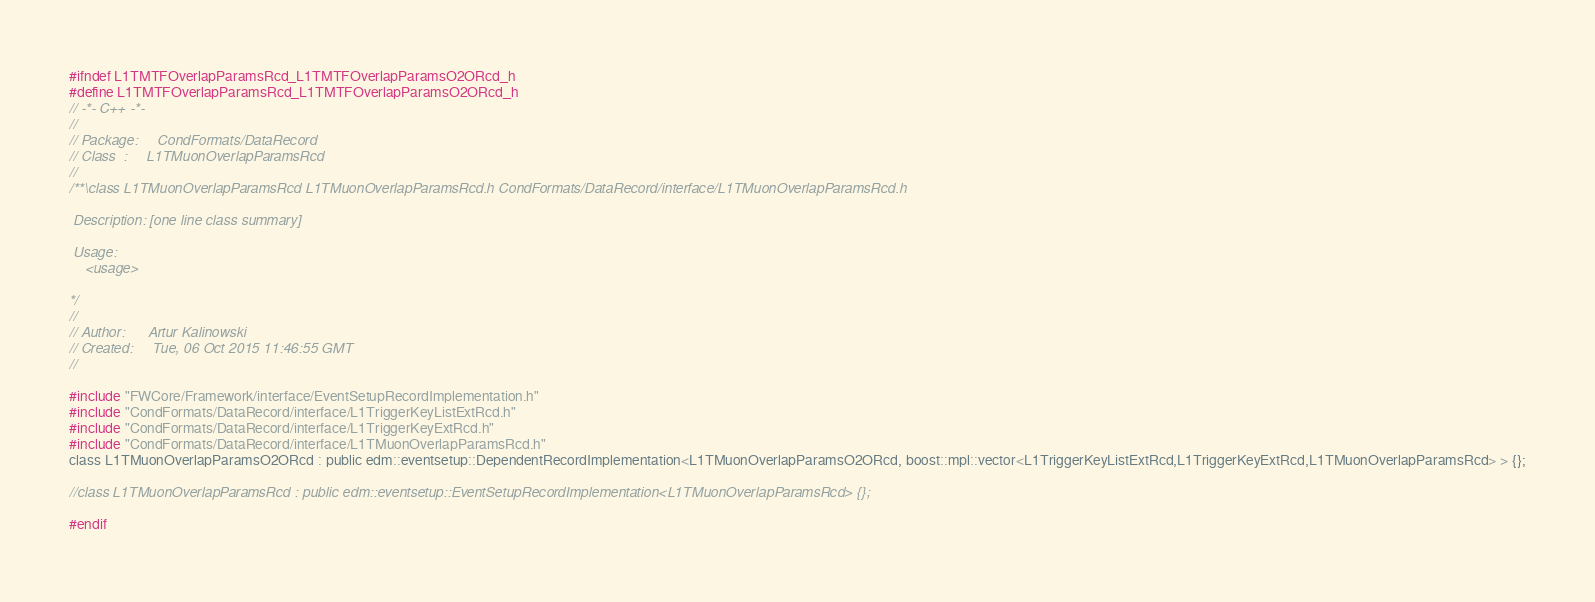Convert code to text. <code><loc_0><loc_0><loc_500><loc_500><_C_>#ifndef L1TMTFOverlapParamsRcd_L1TMTFOverlapParamsO2ORcd_h
#define L1TMTFOverlapParamsRcd_L1TMTFOverlapParamsO2ORcd_h
// -*- C++ -*-
//
// Package:     CondFormats/DataRecord
// Class  :     L1TMuonOverlapParamsRcd
// 
/**\class L1TMuonOverlapParamsRcd L1TMuonOverlapParamsRcd.h CondFormats/DataRecord/interface/L1TMuonOverlapParamsRcd.h

 Description: [one line class summary]

 Usage:
    <usage>

*/
//
// Author:      Artur Kalinowski
// Created:     Tue, 06 Oct 2015 11:46:55 GMT
//

#include "FWCore/Framework/interface/EventSetupRecordImplementation.h"
#include "CondFormats/DataRecord/interface/L1TriggerKeyListExtRcd.h"
#include "CondFormats/DataRecord/interface/L1TriggerKeyExtRcd.h"
#include "CondFormats/DataRecord/interface/L1TMuonOverlapParamsRcd.h"
class L1TMuonOverlapParamsO2ORcd : public edm::eventsetup::DependentRecordImplementation<L1TMuonOverlapParamsO2ORcd, boost::mpl::vector<L1TriggerKeyListExtRcd,L1TriggerKeyExtRcd,L1TMuonOverlapParamsRcd> > {};

//class L1TMuonOverlapParamsRcd : public edm::eventsetup::EventSetupRecordImplementation<L1TMuonOverlapParamsRcd> {};

#endif
</code> 